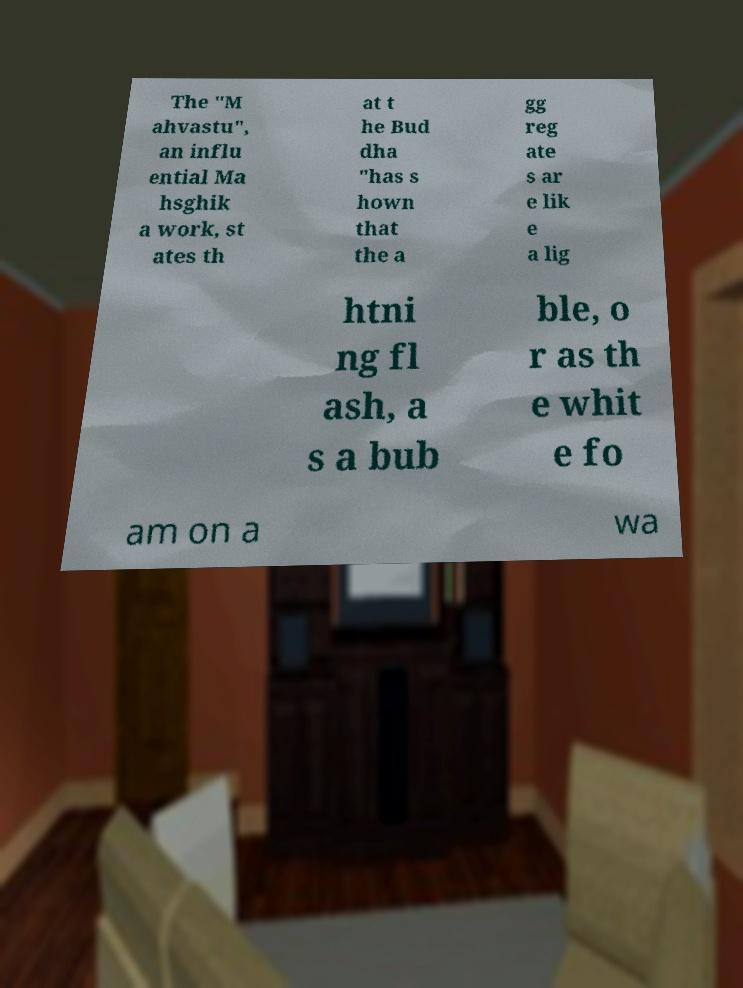Can you read and provide the text displayed in the image?This photo seems to have some interesting text. Can you extract and type it out for me? The "M ahvastu", an influ ential Ma hsghik a work, st ates th at t he Bud dha "has s hown that the a gg reg ate s ar e lik e a lig htni ng fl ash, a s a bub ble, o r as th e whit e fo am on a wa 